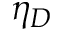Convert formula to latex. <formula><loc_0><loc_0><loc_500><loc_500>\eta _ { D }</formula> 